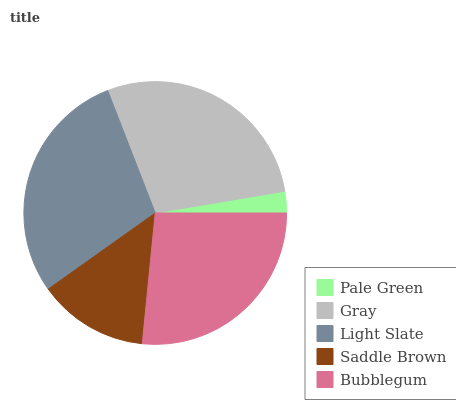Is Pale Green the minimum?
Answer yes or no. Yes. Is Light Slate the maximum?
Answer yes or no. Yes. Is Gray the minimum?
Answer yes or no. No. Is Gray the maximum?
Answer yes or no. No. Is Gray greater than Pale Green?
Answer yes or no. Yes. Is Pale Green less than Gray?
Answer yes or no. Yes. Is Pale Green greater than Gray?
Answer yes or no. No. Is Gray less than Pale Green?
Answer yes or no. No. Is Bubblegum the high median?
Answer yes or no. Yes. Is Bubblegum the low median?
Answer yes or no. Yes. Is Saddle Brown the high median?
Answer yes or no. No. Is Light Slate the low median?
Answer yes or no. No. 